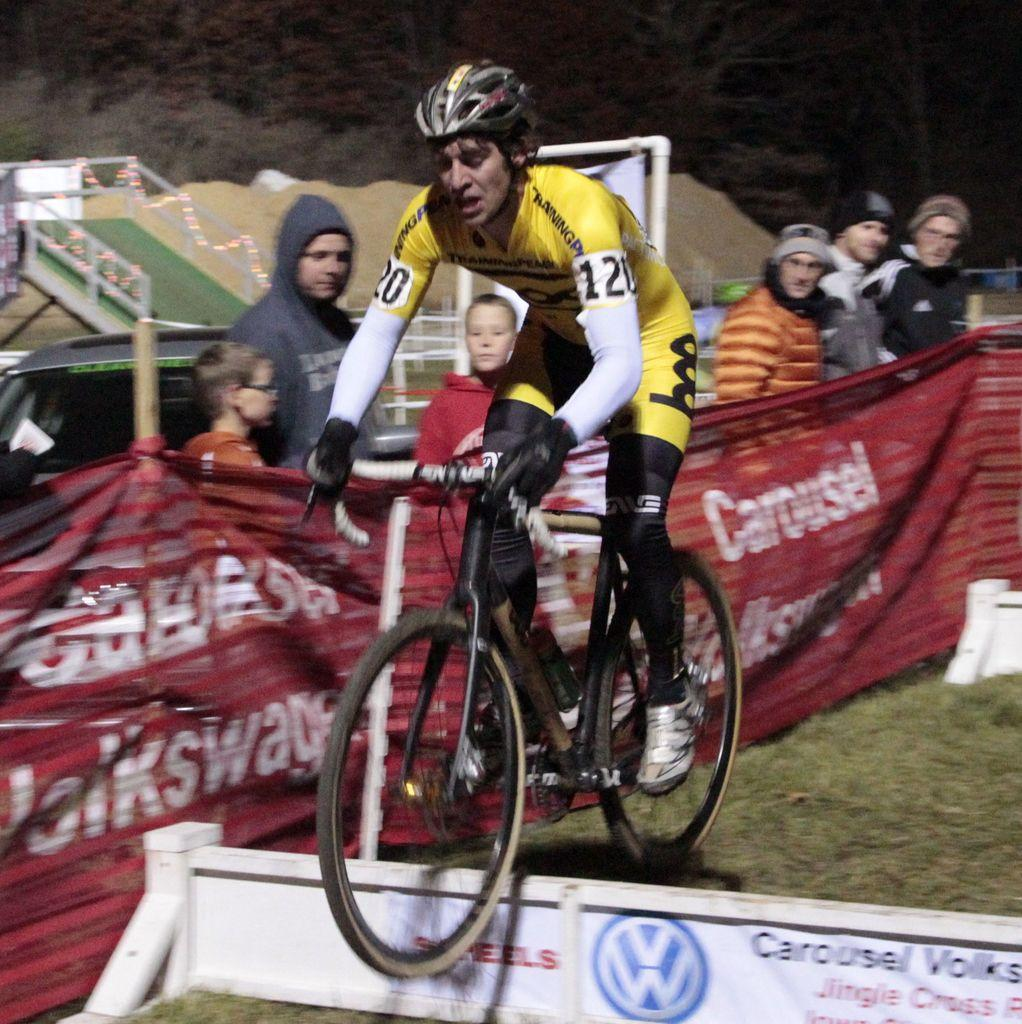What is the main subject of the image? The main subject of the image is a man. What is the man doing in the image? The man is cycling in the image. What is the man riding in the image? The man is riding a cycle in the image. Can you describe the background of the image? There are people visible in the background of the image. What type of grass can be seen growing on the man's fang in the image? There is no grass or fang present in the image; the man is cycling on a cycle. 